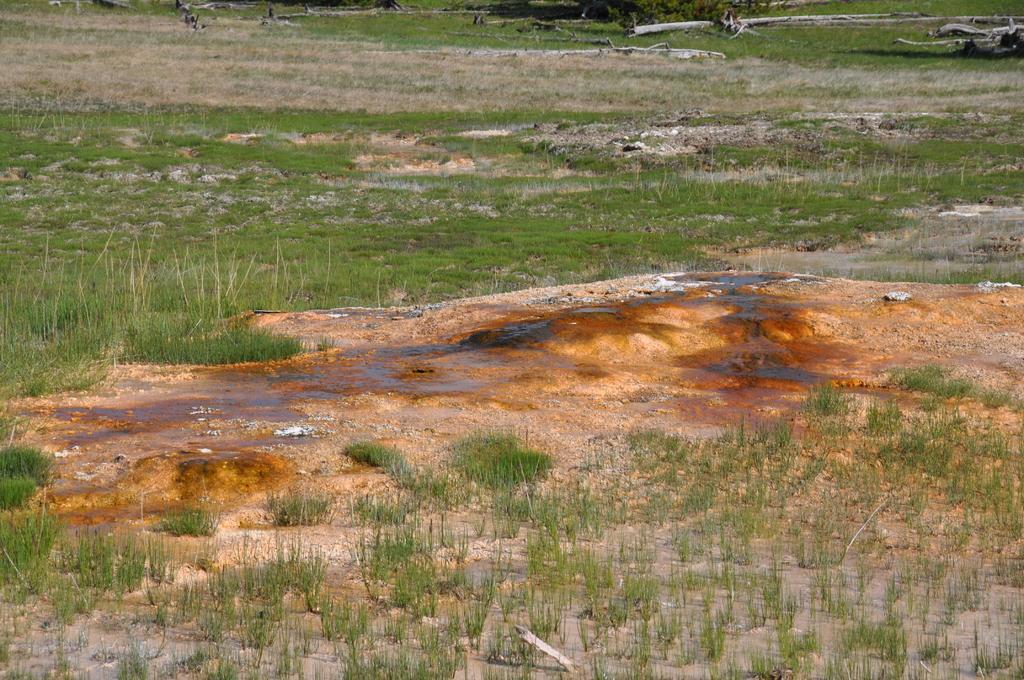Describe this image in one or two sentences. In this image we can see grass on the ground. In the back there are tree trunks. 